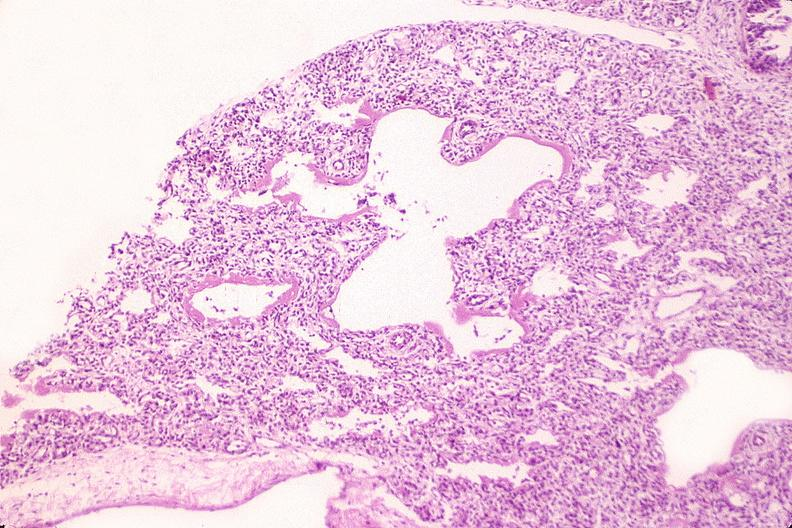what is present?
Answer the question using a single word or phrase. Respiratory 